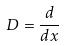<formula> <loc_0><loc_0><loc_500><loc_500>D = \frac { d } { d x }</formula> 